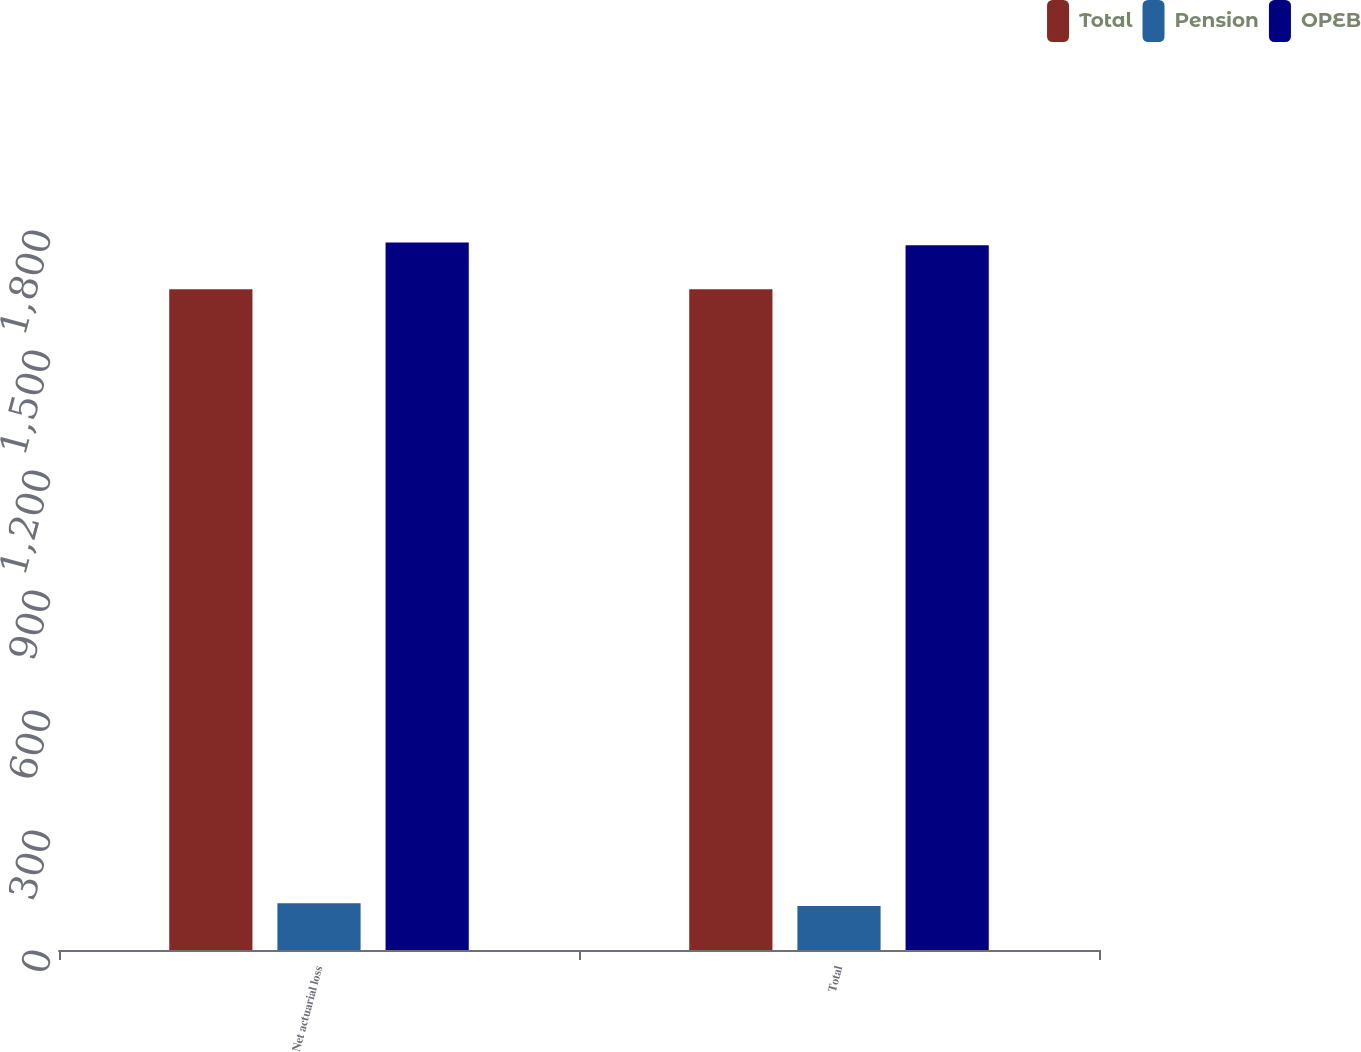<chart> <loc_0><loc_0><loc_500><loc_500><stacked_bar_chart><ecel><fcel>Net actuarial loss<fcel>Total<nl><fcel>Total<fcel>1652<fcel>1652<nl><fcel>Pension<fcel>117<fcel>110<nl><fcel>OPEB<fcel>1769<fcel>1762<nl></chart> 